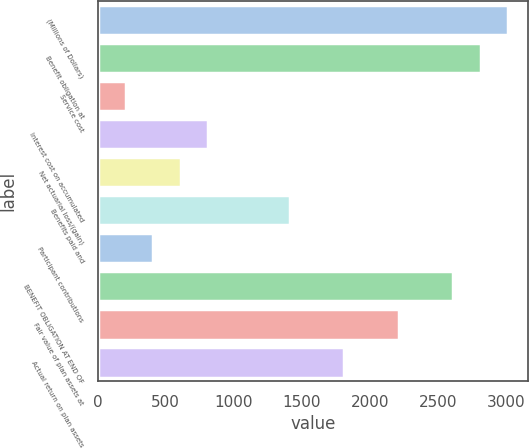<chart> <loc_0><loc_0><loc_500><loc_500><bar_chart><fcel>(Millions of Dollars)<fcel>Benefit obligation at<fcel>Service cost<fcel>Interest cost on accumulated<fcel>Net actuarial loss/(gain)<fcel>Benefits paid and<fcel>Participant contributions<fcel>BENEFIT OBLIGATION AT END OF<fcel>Fair value of plan assets at<fcel>Actual return on plan assets<nl><fcel>3015<fcel>2814.6<fcel>209.4<fcel>810.6<fcel>610.2<fcel>1411.8<fcel>409.8<fcel>2614.2<fcel>2213.4<fcel>1812.6<nl></chart> 